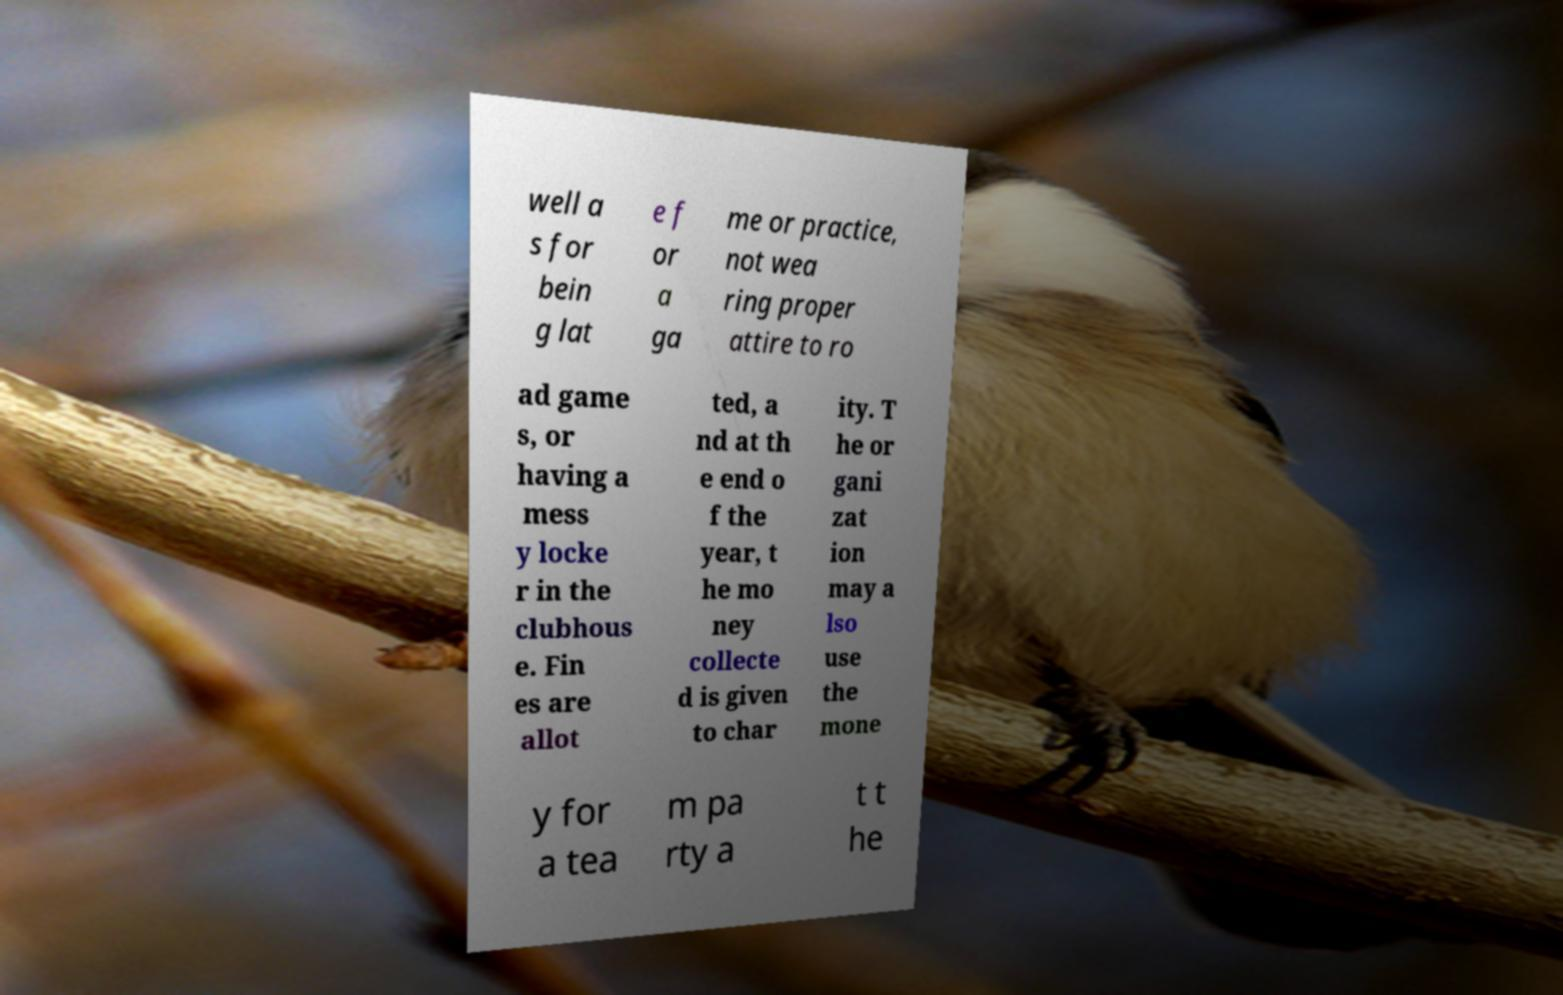There's text embedded in this image that I need extracted. Can you transcribe it verbatim? well a s for bein g lat e f or a ga me or practice, not wea ring proper attire to ro ad game s, or having a mess y locke r in the clubhous e. Fin es are allot ted, a nd at th e end o f the year, t he mo ney collecte d is given to char ity. T he or gani zat ion may a lso use the mone y for a tea m pa rty a t t he 